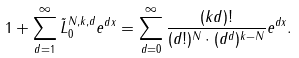Convert formula to latex. <formula><loc_0><loc_0><loc_500><loc_500>1 + \sum _ { d = 1 } ^ { \infty } \tilde { L } _ { 0 } ^ { N , k , d } e ^ { d x } = \sum _ { d = 0 } ^ { \infty } \frac { ( k d ) ! } { ( d ! ) ^ { N } \cdot ( d ^ { d } ) ^ { k - N } } e ^ { d x } .</formula> 